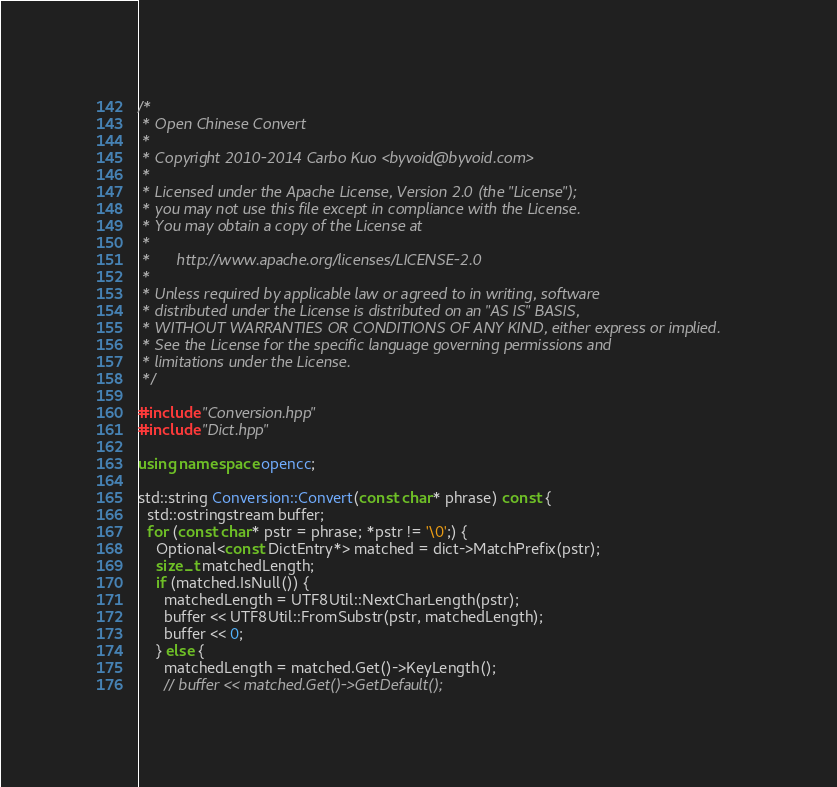Convert code to text. <code><loc_0><loc_0><loc_500><loc_500><_C++_>/*
 * Open Chinese Convert
 *
 * Copyright 2010-2014 Carbo Kuo <byvoid@byvoid.com>
 *
 * Licensed under the Apache License, Version 2.0 (the "License");
 * you may not use this file except in compliance with the License.
 * You may obtain a copy of the License at
 *
 *      http://www.apache.org/licenses/LICENSE-2.0
 *
 * Unless required by applicable law or agreed to in writing, software
 * distributed under the License is distributed on an "AS IS" BASIS,
 * WITHOUT WARRANTIES OR CONDITIONS OF ANY KIND, either express or implied.
 * See the License for the specific language governing permissions and
 * limitations under the License.
 */

#include "Conversion.hpp"
#include "Dict.hpp"

using namespace opencc;

std::string Conversion::Convert(const char* phrase) const {
  std::ostringstream buffer;
  for (const char* pstr = phrase; *pstr != '\0';) {
    Optional<const DictEntry*> matched = dict->MatchPrefix(pstr);
    size_t matchedLength;
    if (matched.IsNull()) {
      matchedLength = UTF8Util::NextCharLength(pstr);
      buffer << UTF8Util::FromSubstr(pstr, matchedLength);
      buffer << 0;
    } else {
      matchedLength = matched.Get()->KeyLength();
      // buffer << matched.Get()->GetDefault();</code> 